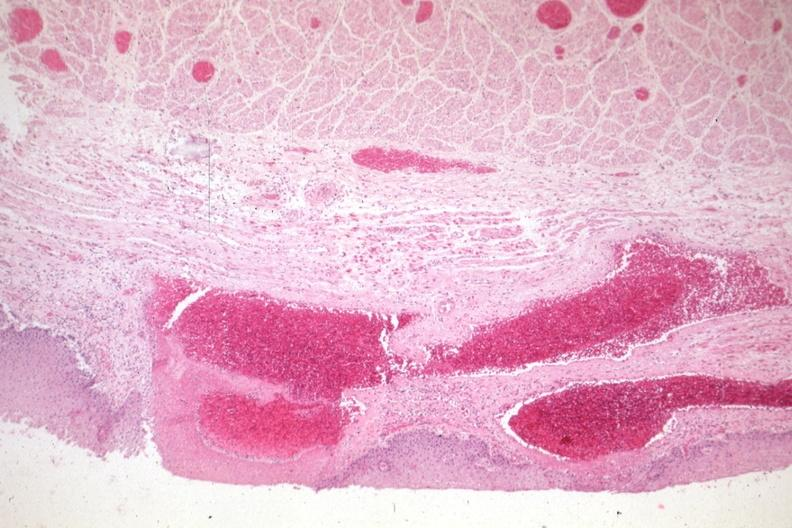s esophagus present?
Answer the question using a single word or phrase. Yes 